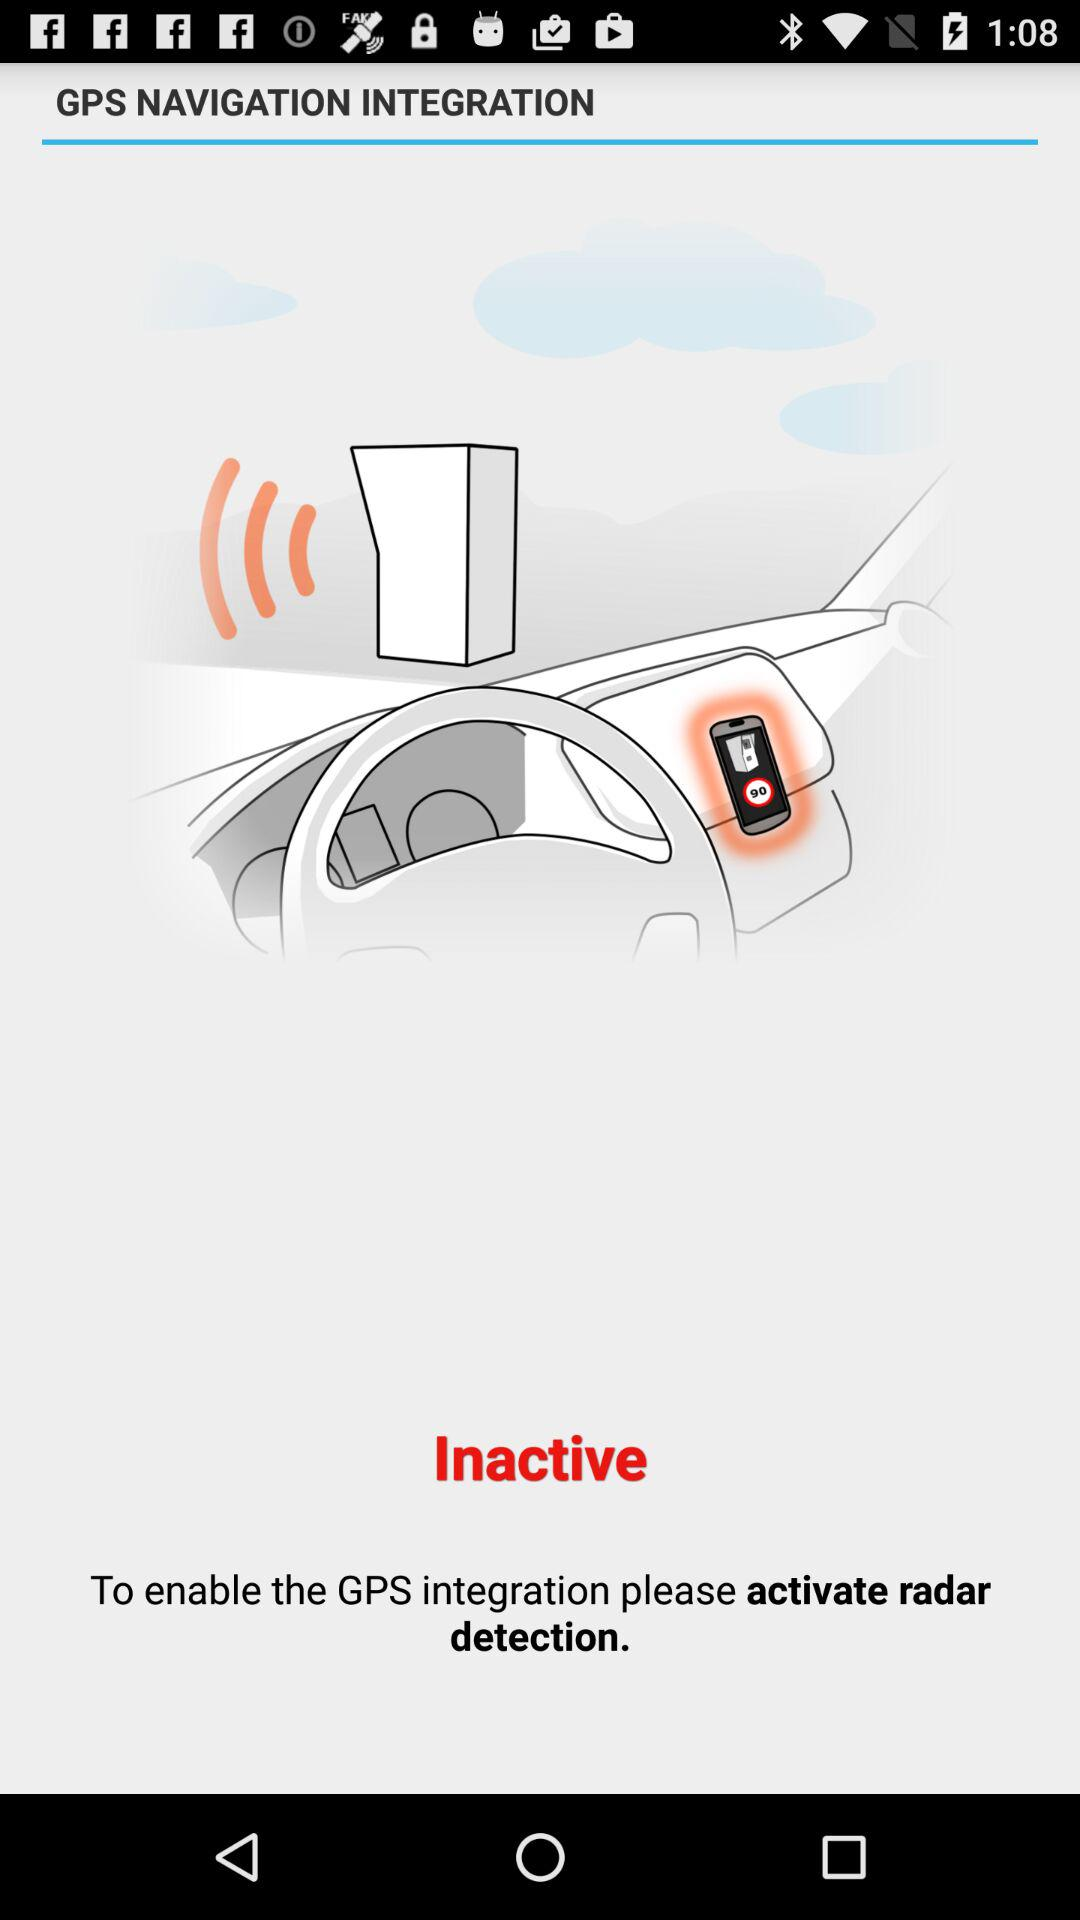What's the status of "GPS NAVIGATION INTEGRATION"? The status is "Inactive". 